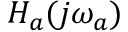Convert formula to latex. <formula><loc_0><loc_0><loc_500><loc_500>H _ { a } ( j \omega _ { a } )</formula> 